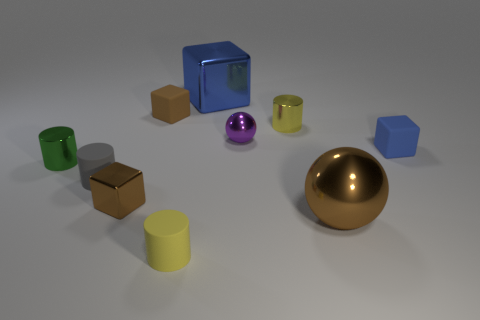Subtract all brown metallic cubes. How many cubes are left? 3 Subtract all gray cubes. How many yellow cylinders are left? 2 Subtract all blue cubes. How many cubes are left? 2 Subtract 2 balls. How many balls are left? 0 Add 1 blue rubber balls. How many blue rubber balls exist? 1 Subtract 0 green balls. How many objects are left? 10 Subtract all cylinders. How many objects are left? 6 Subtract all green cylinders. Subtract all green balls. How many cylinders are left? 3 Subtract all blue objects. Subtract all brown metal cubes. How many objects are left? 7 Add 8 small metal cylinders. How many small metal cylinders are left? 10 